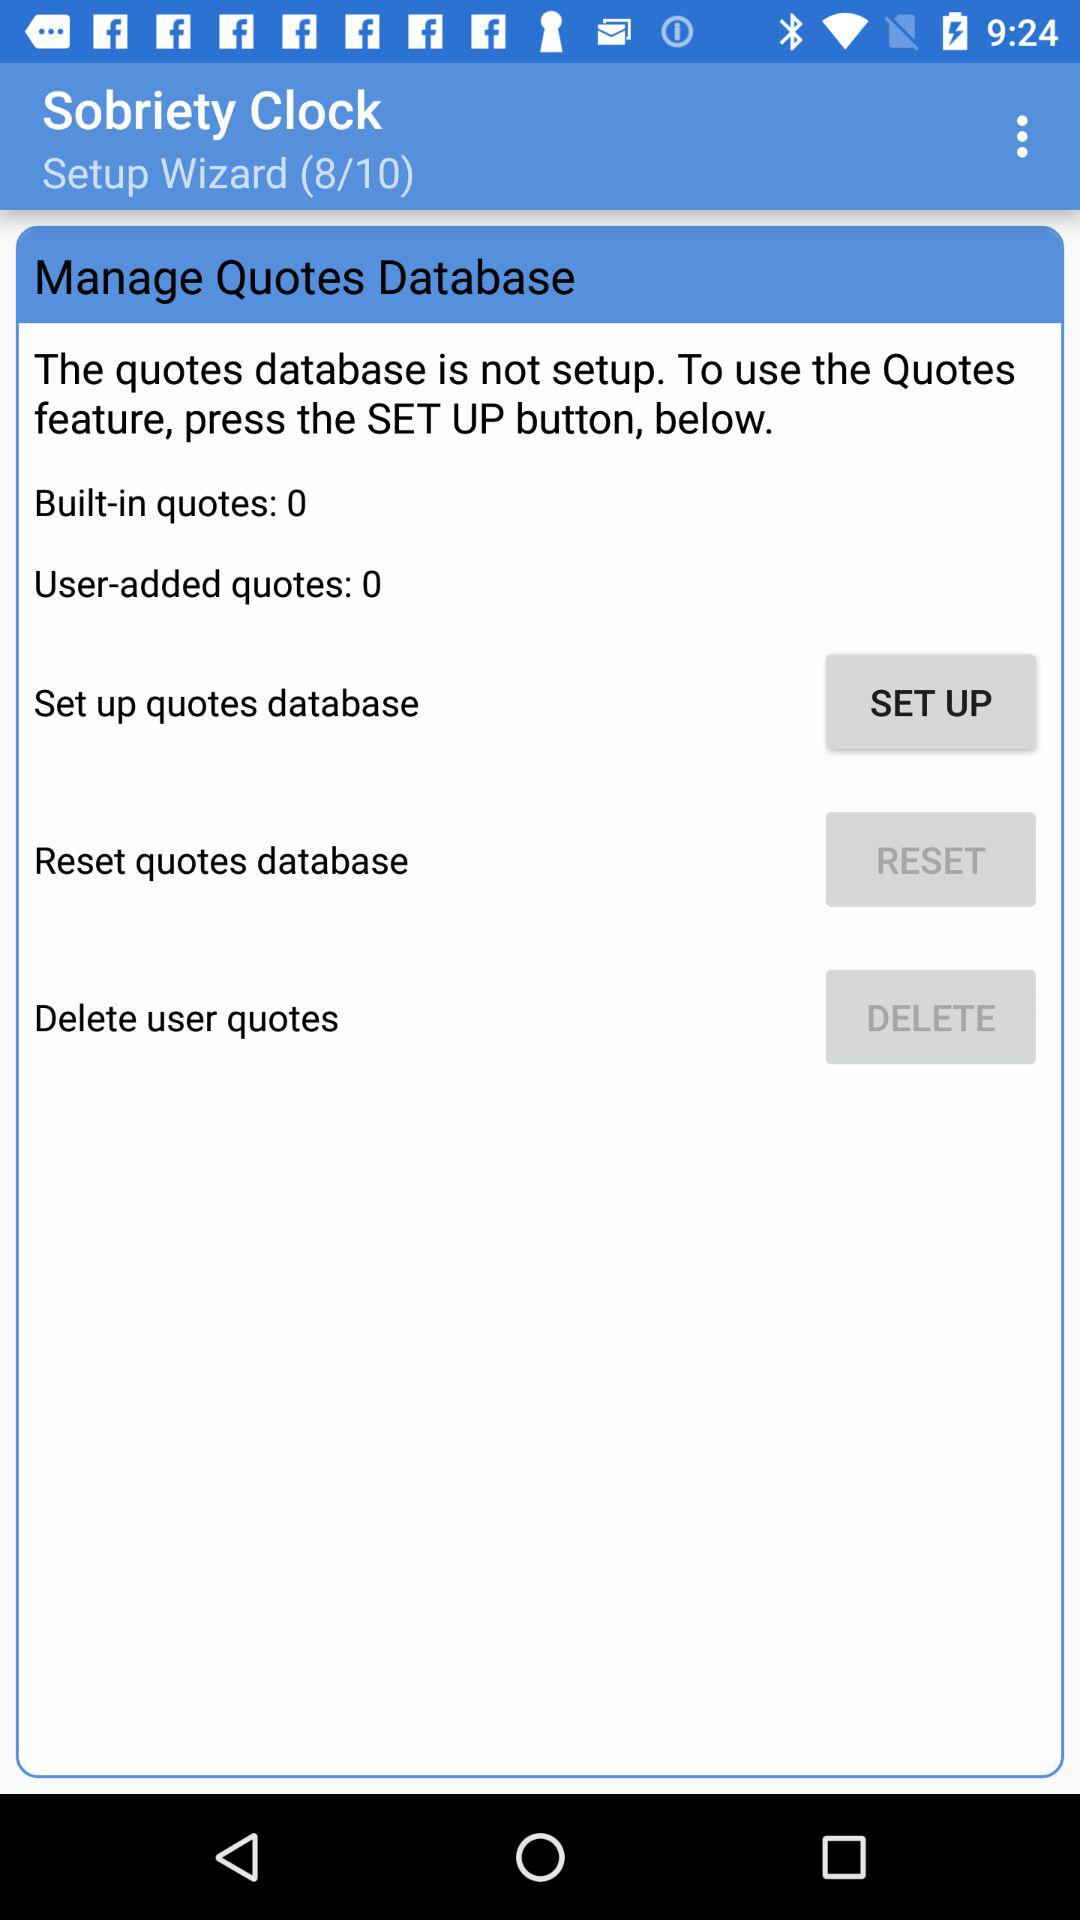What is the total number of setup wizards? The total number of setup wizards is 10. 